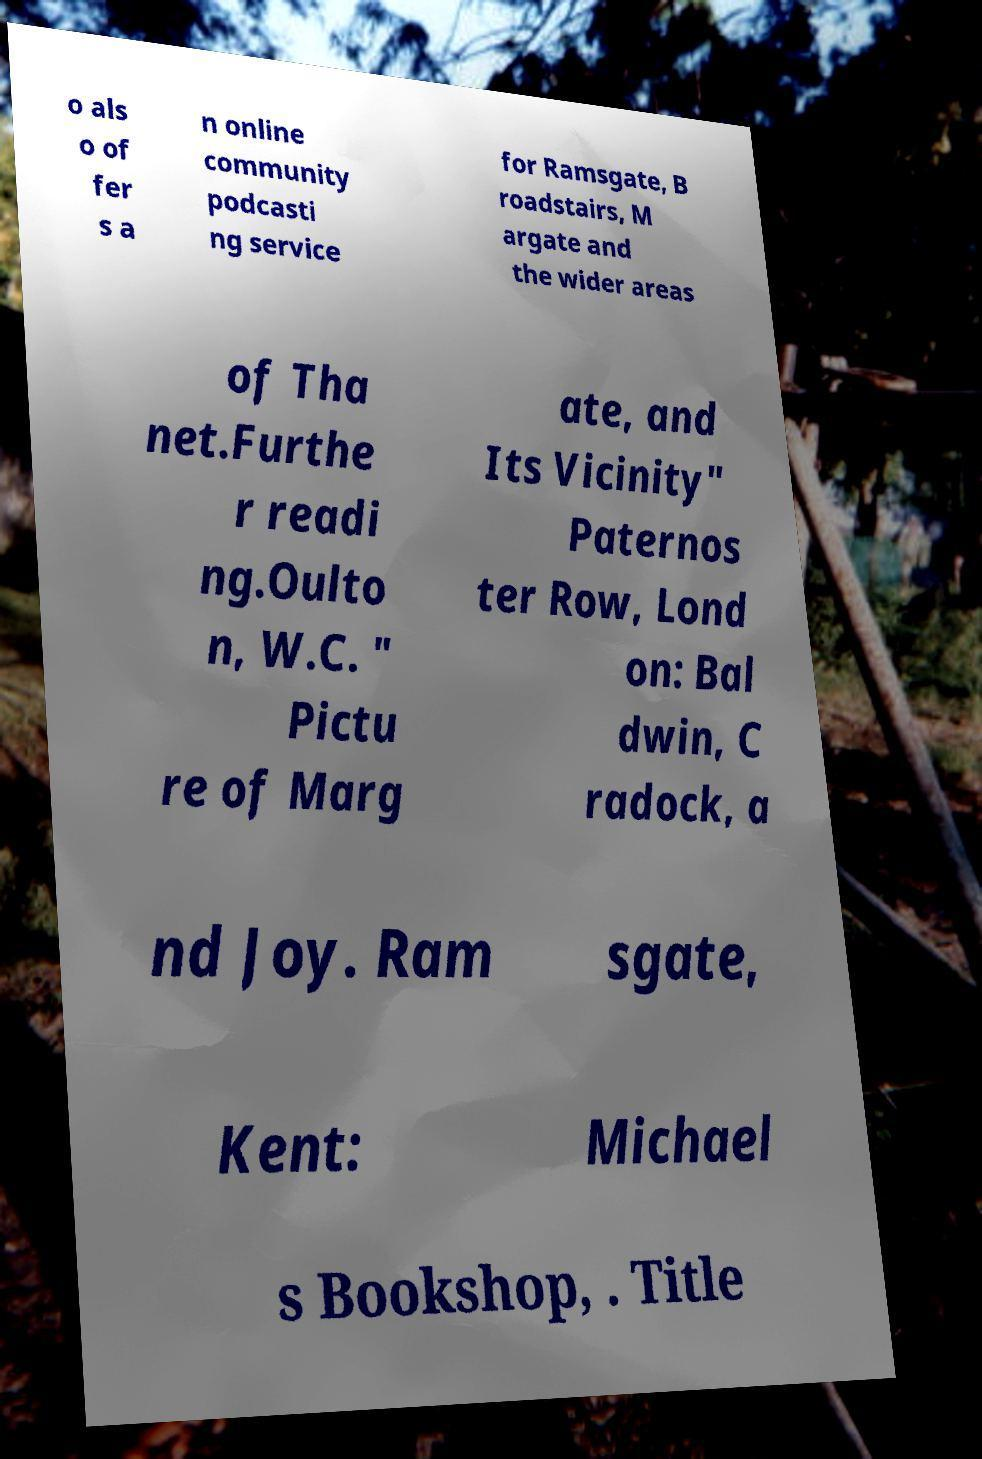Can you read and provide the text displayed in the image?This photo seems to have some interesting text. Can you extract and type it out for me? o als o of fer s a n online community podcasti ng service for Ramsgate, B roadstairs, M argate and the wider areas of Tha net.Furthe r readi ng.Oulto n, W.C. " Pictu re of Marg ate, and Its Vicinity" Paternos ter Row, Lond on: Bal dwin, C radock, a nd Joy. Ram sgate, Kent: Michael s Bookshop, . Title 